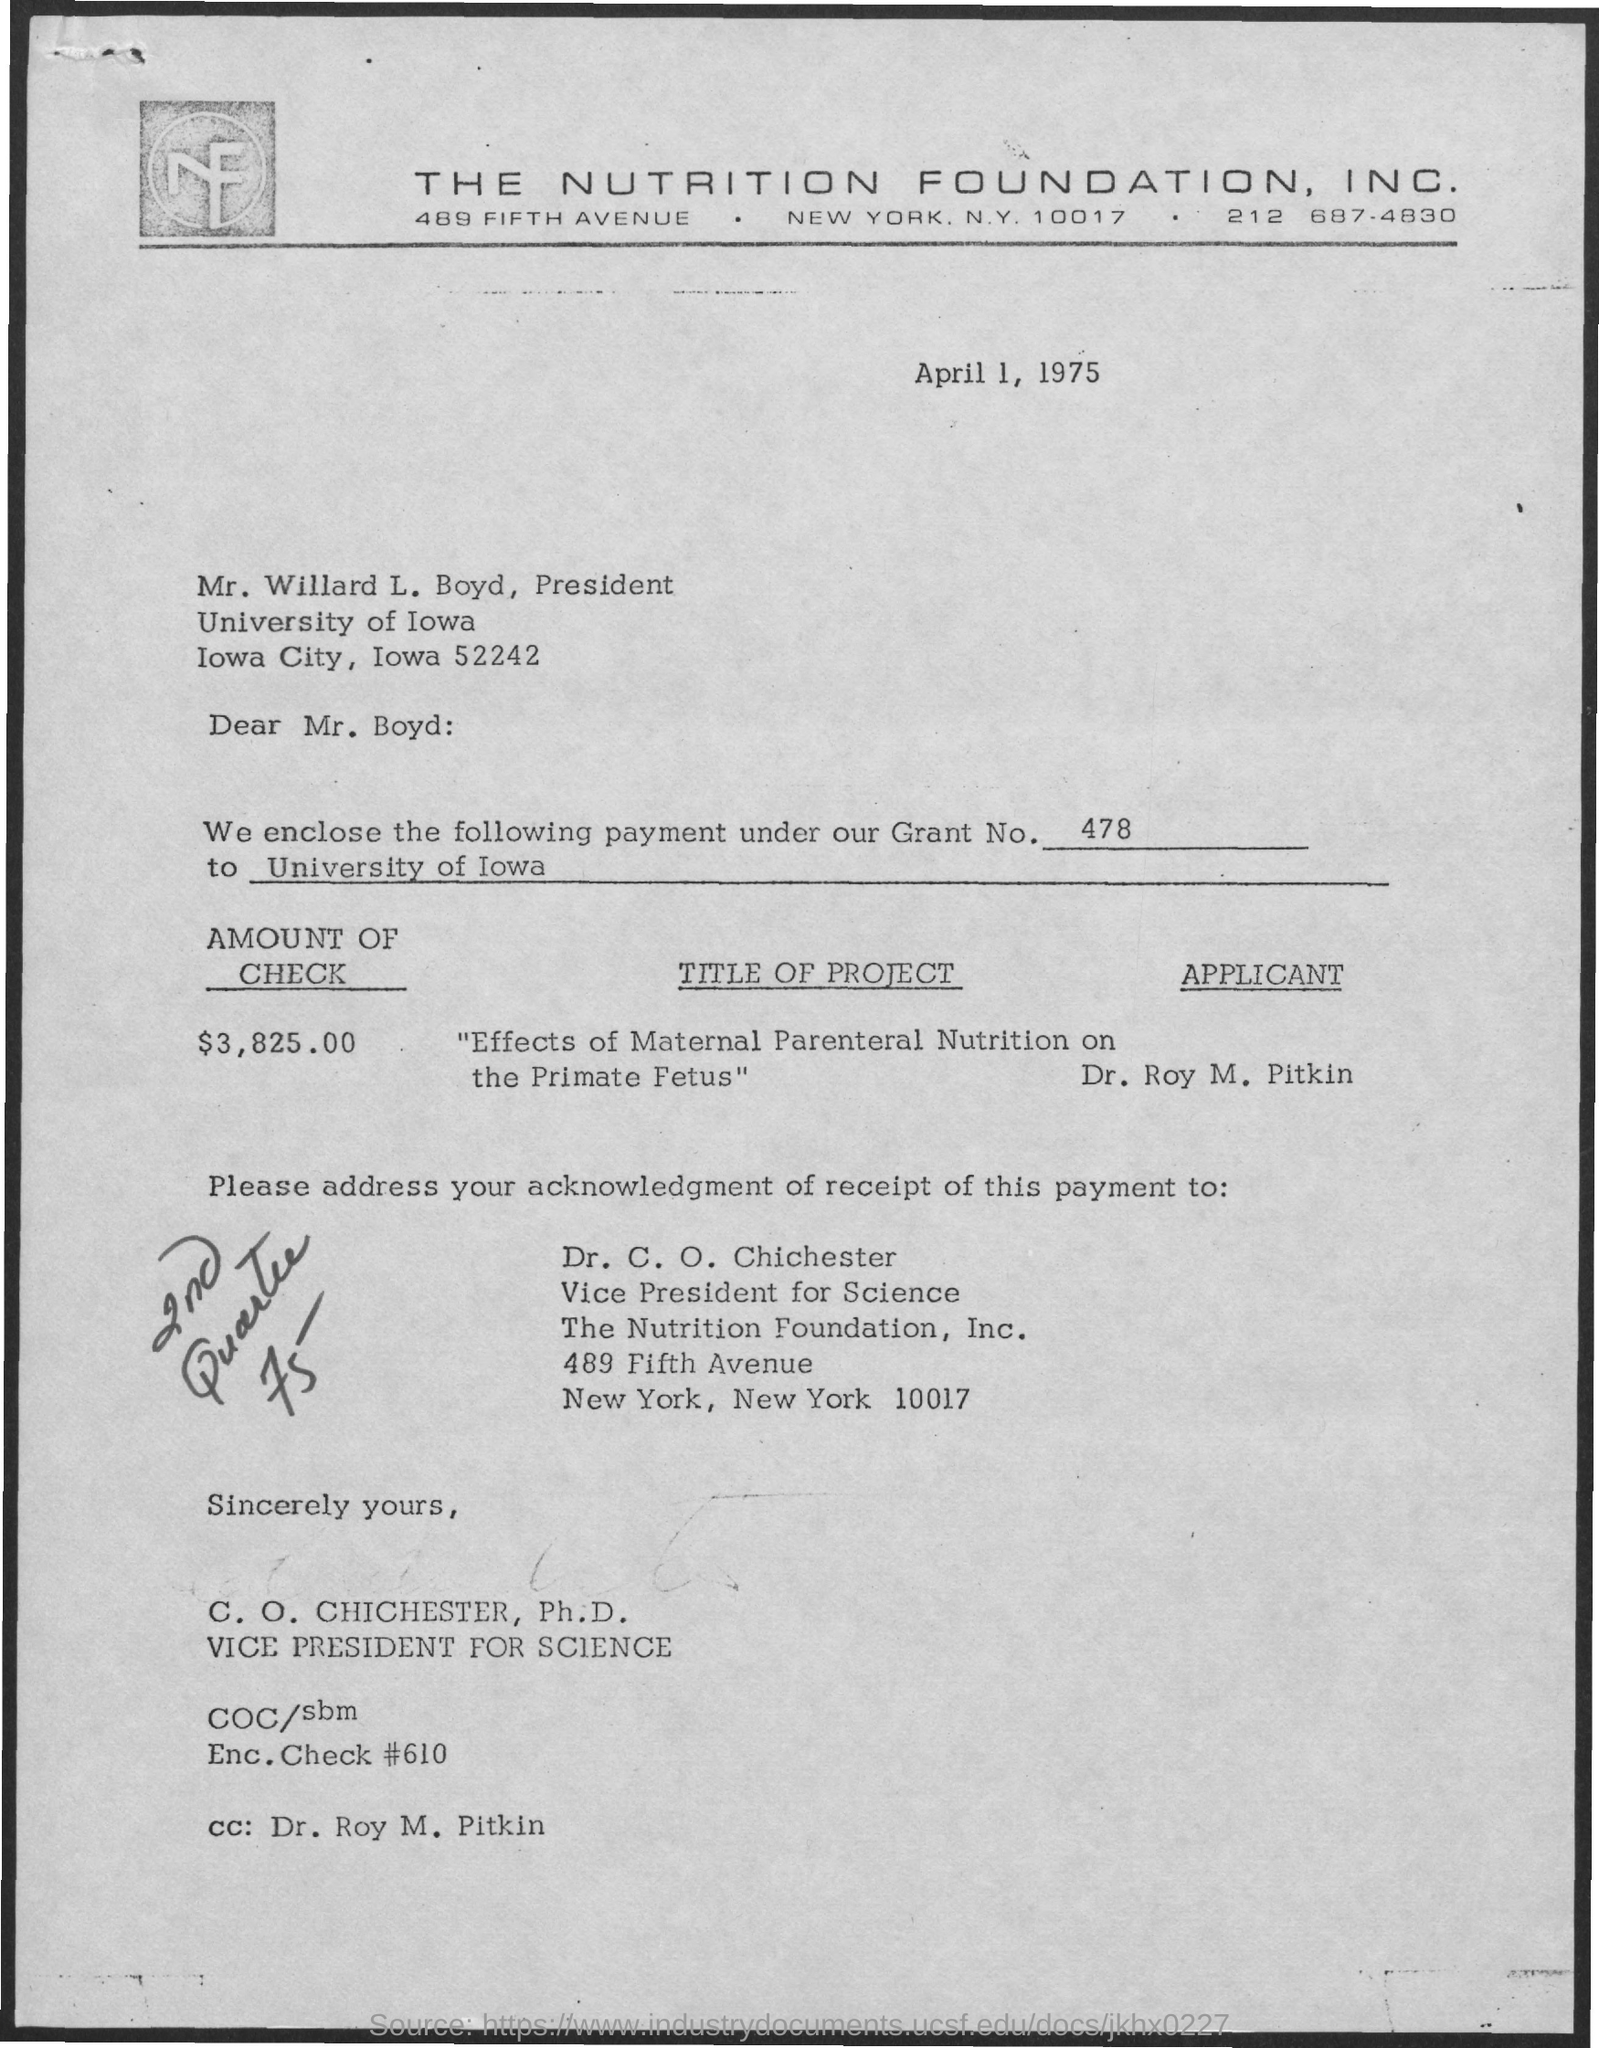What is the name of the president ?
Ensure brevity in your answer.  Mr. Willard L. Boyd. In which city The nutrition foundation Inc is located ?
Your answer should be compact. NEW YORK. What is the name of the applicant ?
Your response must be concise. Dr . Roy M. Pitkin. Who is the vice president for science
Ensure brevity in your answer.  Dr. C. O. Chichester. What is the grant no mentioned ?
Keep it short and to the point. 478. Who is mentioned in the cc?
Your response must be concise. Dr . Roy M. Pitkin. 